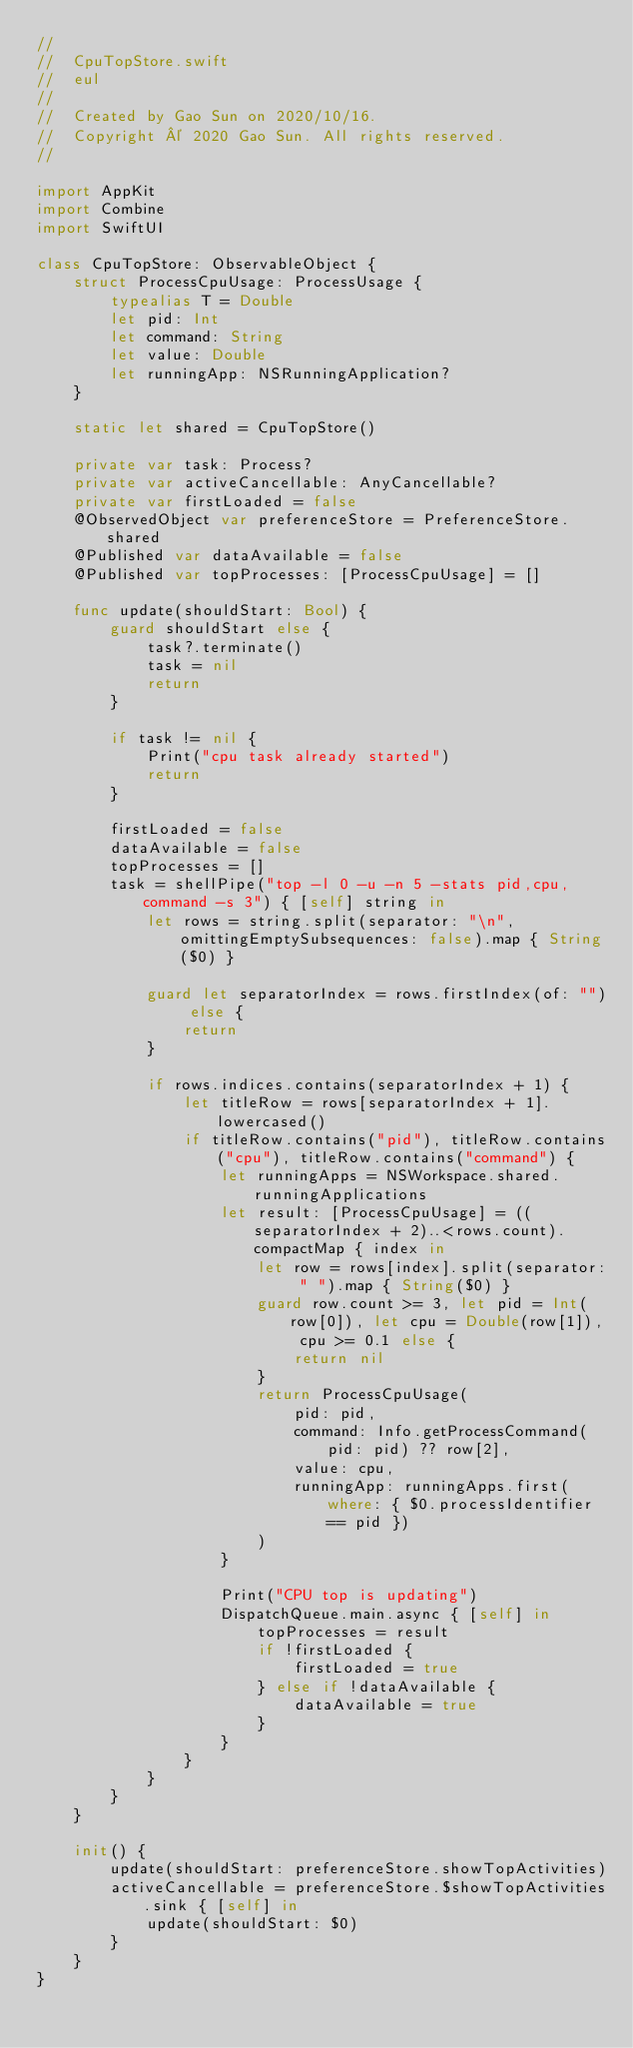<code> <loc_0><loc_0><loc_500><loc_500><_Swift_>//
//  CpuTopStore.swift
//  eul
//
//  Created by Gao Sun on 2020/10/16.
//  Copyright © 2020 Gao Sun. All rights reserved.
//

import AppKit
import Combine
import SwiftUI

class CpuTopStore: ObservableObject {
    struct ProcessCpuUsage: ProcessUsage {
        typealias T = Double
        let pid: Int
        let command: String
        let value: Double
        let runningApp: NSRunningApplication?
    }

    static let shared = CpuTopStore()

    private var task: Process?
    private var activeCancellable: AnyCancellable?
    private var firstLoaded = false
    @ObservedObject var preferenceStore = PreferenceStore.shared
    @Published var dataAvailable = false
    @Published var topProcesses: [ProcessCpuUsage] = []

    func update(shouldStart: Bool) {
        guard shouldStart else {
            task?.terminate()
            task = nil
            return
        }

        if task != nil {
            Print("cpu task already started")
            return
        }

        firstLoaded = false
        dataAvailable = false
        topProcesses = []
        task = shellPipe("top -l 0 -u -n 5 -stats pid,cpu,command -s 3") { [self] string in
            let rows = string.split(separator: "\n", omittingEmptySubsequences: false).map { String($0) }

            guard let separatorIndex = rows.firstIndex(of: "") else {
                return
            }

            if rows.indices.contains(separatorIndex + 1) {
                let titleRow = rows[separatorIndex + 1].lowercased()
                if titleRow.contains("pid"), titleRow.contains("cpu"), titleRow.contains("command") {
                    let runningApps = NSWorkspace.shared.runningApplications
                    let result: [ProcessCpuUsage] = ((separatorIndex + 2)..<rows.count).compactMap { index in
                        let row = rows[index].split(separator: " ").map { String($0) }
                        guard row.count >= 3, let pid = Int(row[0]), let cpu = Double(row[1]), cpu >= 0.1 else {
                            return nil
                        }
                        return ProcessCpuUsage(
                            pid: pid,
                            command: Info.getProcessCommand(pid: pid) ?? row[2],
                            value: cpu,
                            runningApp: runningApps.first(where: { $0.processIdentifier == pid })
                        )
                    }

                    Print("CPU top is updating")
                    DispatchQueue.main.async { [self] in
                        topProcesses = result
                        if !firstLoaded {
                            firstLoaded = true
                        } else if !dataAvailable {
                            dataAvailable = true
                        }
                    }
                }
            }
        }
    }

    init() {
        update(shouldStart: preferenceStore.showTopActivities)
        activeCancellable = preferenceStore.$showTopActivities.sink { [self] in
            update(shouldStart: $0)
        }
    }
}
</code> 